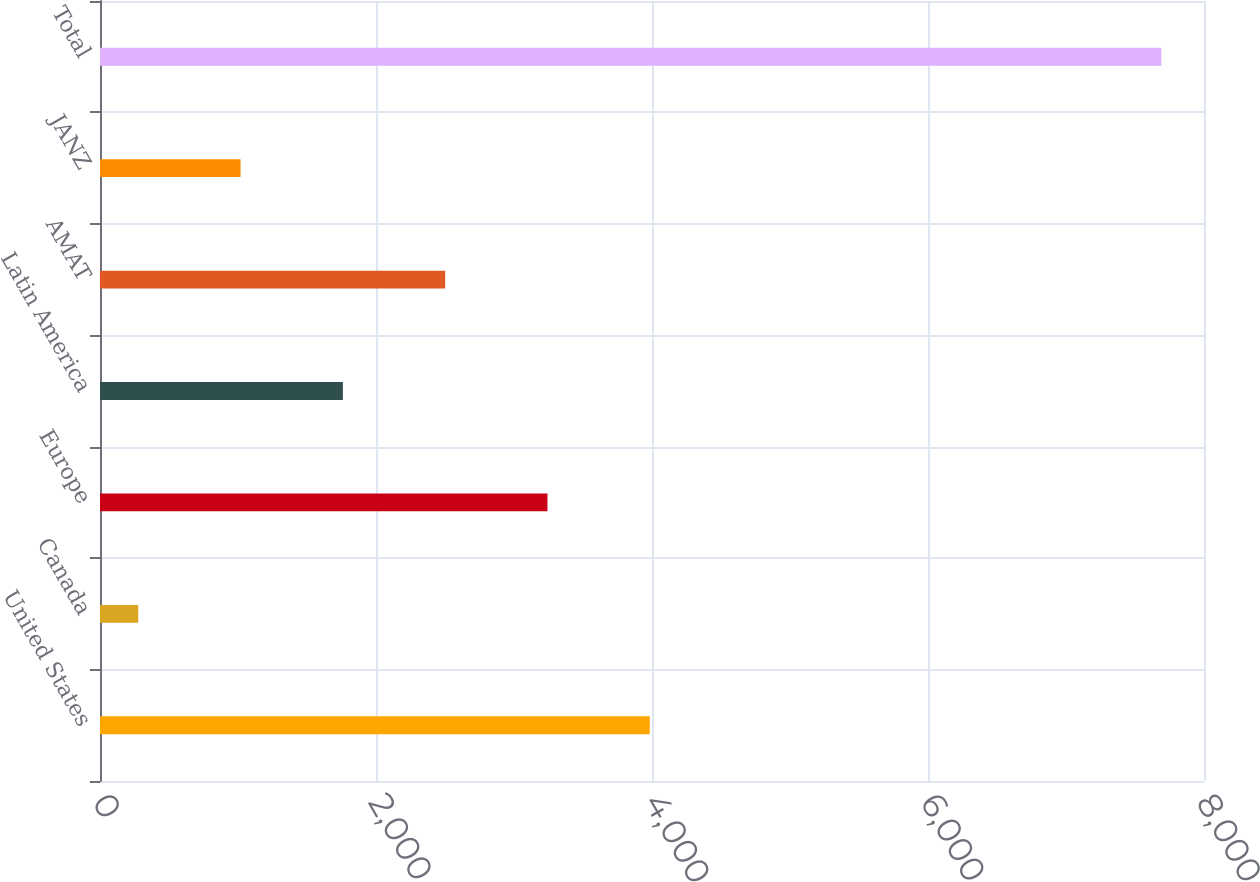<chart> <loc_0><loc_0><loc_500><loc_500><bar_chart><fcel>United States<fcel>Canada<fcel>Europe<fcel>Latin America<fcel>AMAT<fcel>JANZ<fcel>Total<nl><fcel>3984<fcel>277.2<fcel>3242.64<fcel>1759.92<fcel>2501.28<fcel>1018.56<fcel>7690.8<nl></chart> 